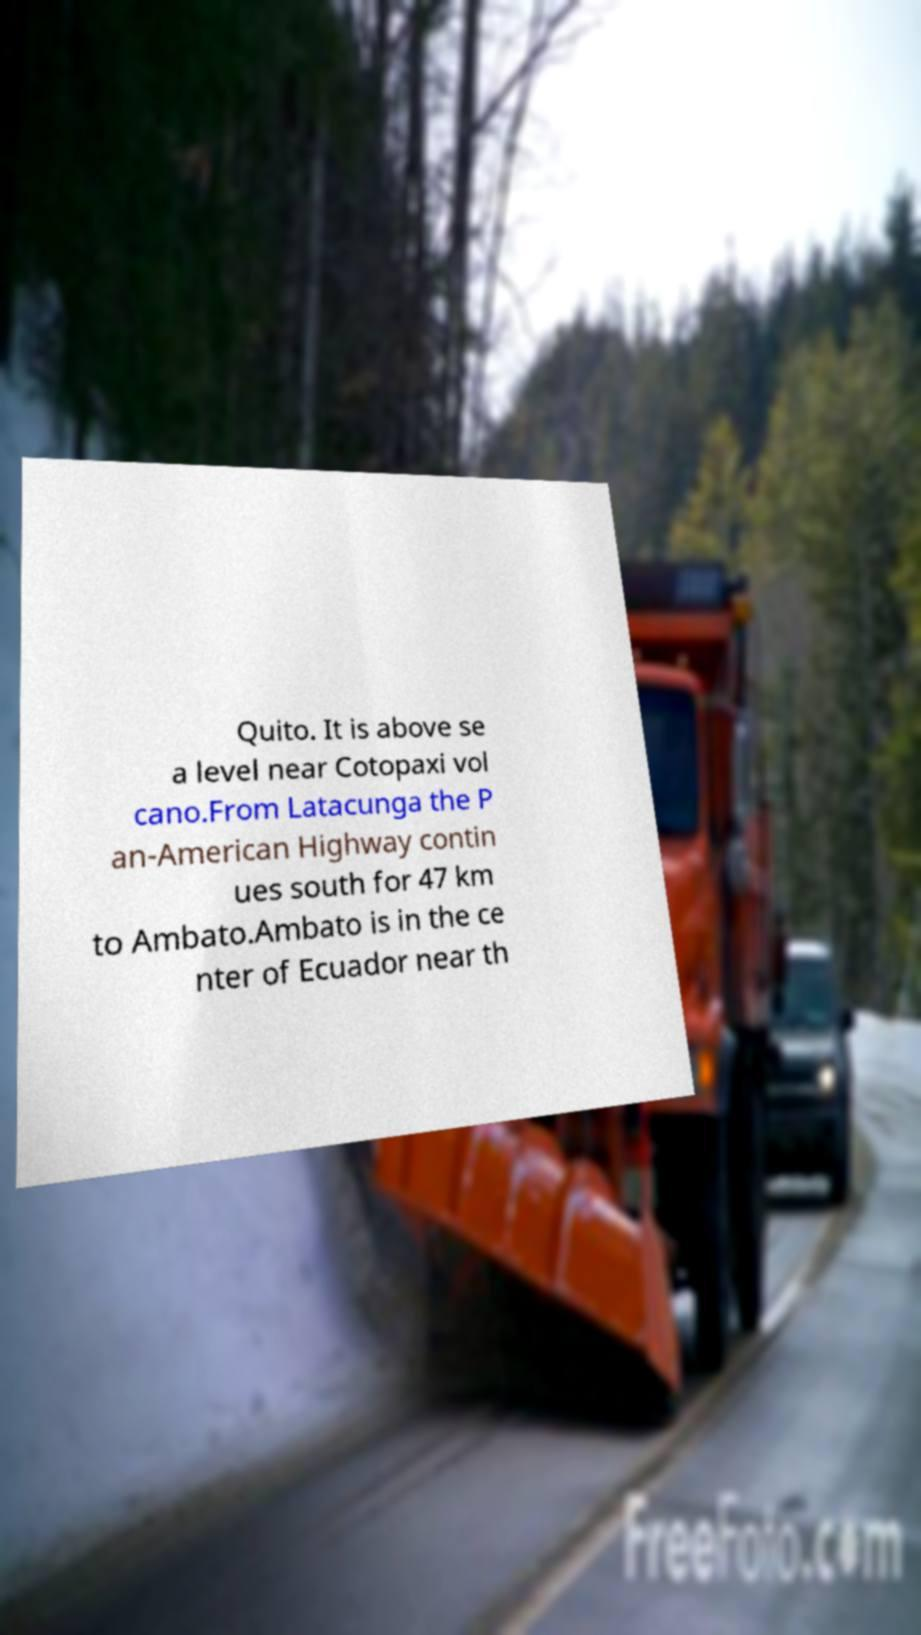Please read and relay the text visible in this image. What does it say? Quito. It is above se a level near Cotopaxi vol cano.From Latacunga the P an-American Highway contin ues south for 47 km to Ambato.Ambato is in the ce nter of Ecuador near th 